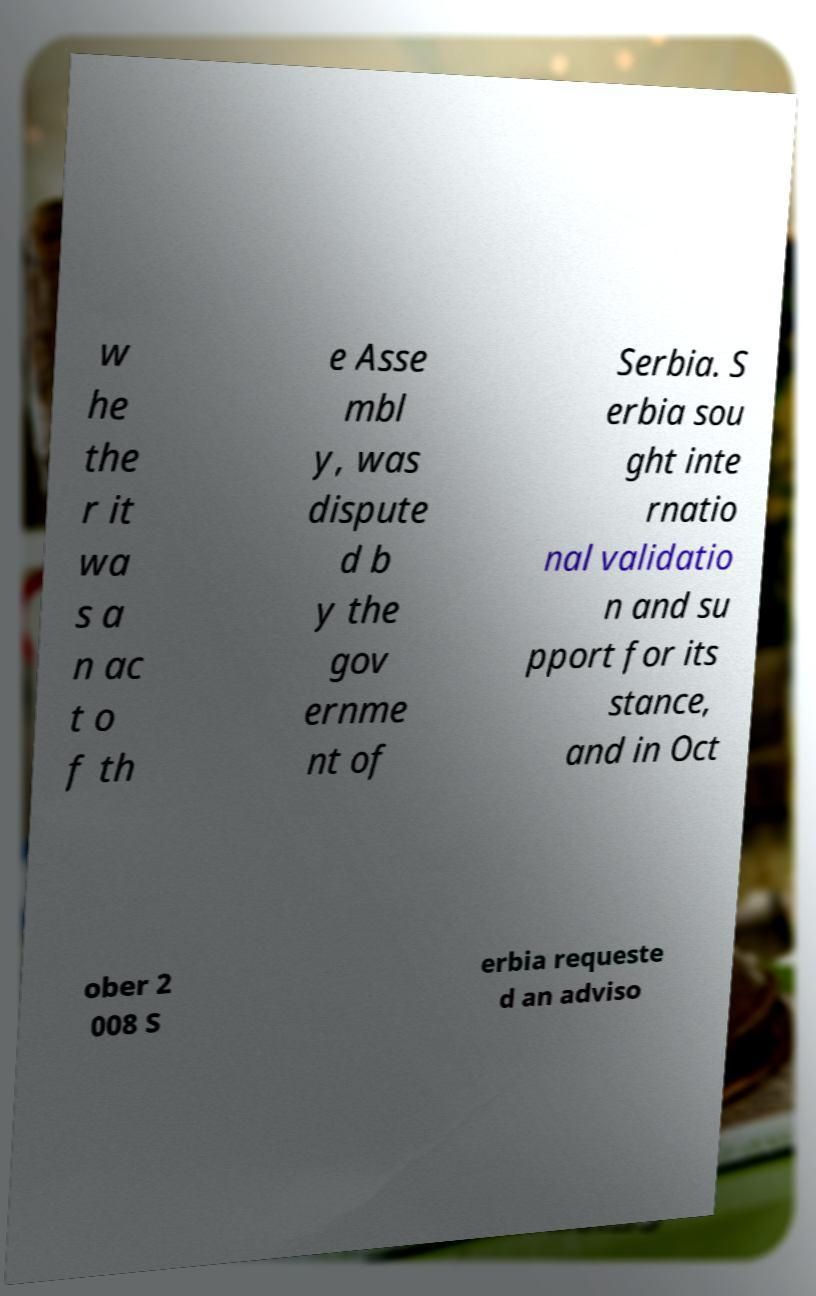For documentation purposes, I need the text within this image transcribed. Could you provide that? w he the r it wa s a n ac t o f th e Asse mbl y, was dispute d b y the gov ernme nt of Serbia. S erbia sou ght inte rnatio nal validatio n and su pport for its stance, and in Oct ober 2 008 S erbia requeste d an adviso 